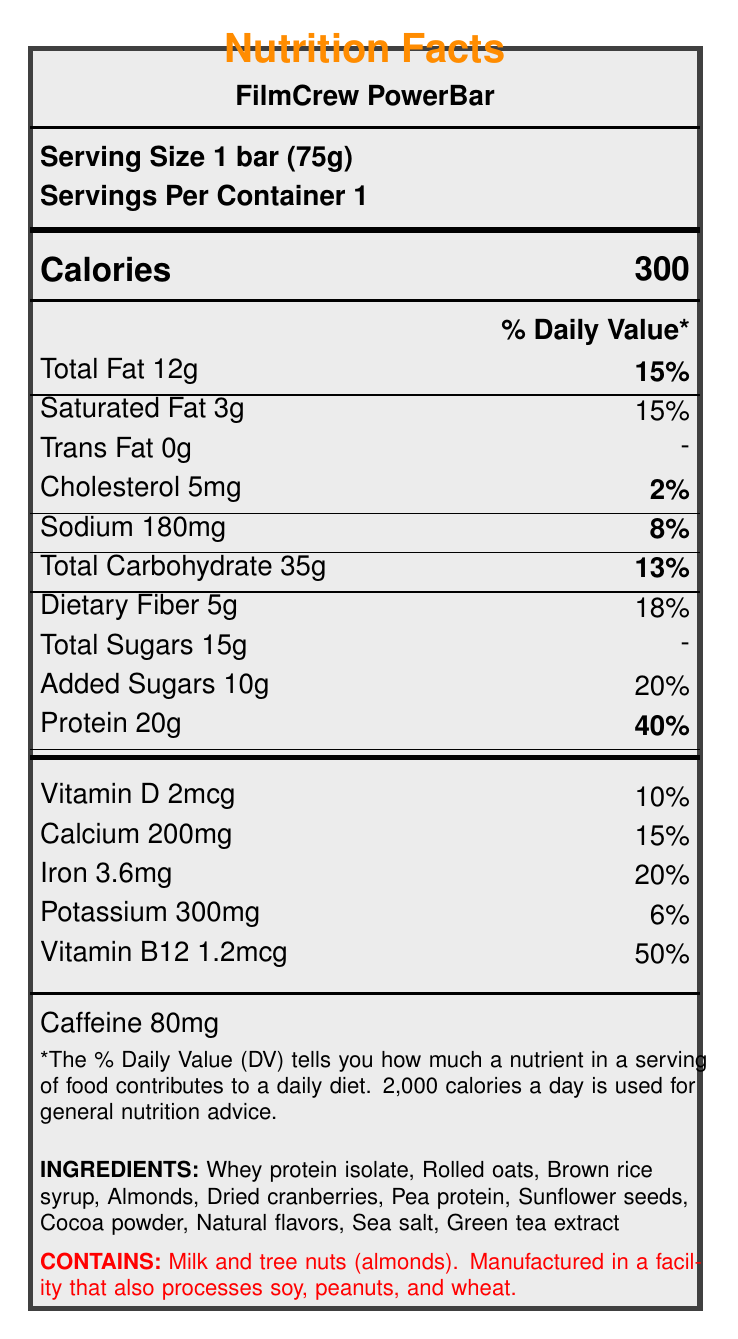what is the serving size of the FilmCrew PowerBar? The serving size is specified as "1 bar (75g)" at the top of the Nutrition Facts label under the "Serving Size" section.
Answer: 1 bar (75g) how many calories are in one serving of the FilmCrew PowerBar? The calories are listed under the "Calories" section in large, bold text that states 300.
Answer: 300 what is the total amount of fat in the FilmCrew PowerBar? The "Total Fat" amount is specified as 12g under the "Nutrient information" section.
Answer: 12g which vitamin has the highest percentage of daily value in the FilmCrew PowerBar? Vitamin B12 has a daily value of 50%, which is higher than other vitamins and minerals listed on the label.
Answer: Vitamin B12 how much protein does the FilmCrew PowerBar provide? The "Protein" amount is specified as 20g under the "Nutrient information" section.
Answer: 20g which of the following ingredients is NOT listed in the FilmCrew PowerBar? A. Whey protein isolate B. Pea protein C. Dried blueberries D. Almonds Dried blueberries are not listed in the ingredient section, whereas whey protein isolate, pea protein, and almonds are.
Answer: C what percentage of the daily value for iron does one serving of the FilmCrew PowerBar provide? A. 10% B. 15% C. 20% D. 25% The label indicates that one serving provides 20% of the daily value for iron.
Answer: C is the FilmCrew PowerBar gluten-free? One of the claims listed on the label states that the product is "Gluten-free."
Answer: Yes does the FilmCrew PowerBar contain any artificial preservatives? The product claims state "No artificial preservatives."
Answer: No summarize the main nutritional highlights of the FilmCrew PowerBar The main highlights include the high protein content, the added benefits of vitamins and minerals, as well as the absence of gluten and artificial preservatives.
Answer: The FilmCrew PowerBar offers 300 calories per serving, with significant nutrients including 20g of protein, 5g of dietary fiber, and 50% of the daily value of Vitamin B12. It contains 12g of total fat, 15g of total sugars, and 80mg of caffeine. It is gluten-free, high in protein, and contains no artificial preservatives. what is the storage recommendation for the FilmCrew PowerBar? The storage instructions state to "Store in a cool, dry place."
Answer: Store in a cool, dry place. who manufactures the FilmCrew PowerBar? The manufacturer information at the end of the document specifies "Produced by VFX Nutrition Labs, Los Angeles, CA 90028."
Answer: VFX Nutrition Labs, Los Angeles, CA 90028 how much caffeine is in the FilmCrew PowerBar? The "Caffeine" amount is specified as 80mg under its respective section.
Answer: 80mg what is the main allergen warning associated with the FilmCrew PowerBar? The allergen information clearly states the presence of milk and tree nuts (almonds) and informs about potential cross-contamination with soy, peanuts, and wheat.
Answer: Contains milk and tree nuts (almonds). Manufactured in a facility that also processes soy, peanuts, and wheat. how many servings are there per container? The number of servings per container is specified as 1 under the "Servings Per Container" section.
Answer: 1 does the FilmCrew PowerBar have any certifications? The label mentions that the product is "Non-GMO Project Verified" and "Kosher."
Answer: Yes, it is Non-GMO Project Verified and Kosher. what is the daily value percentage of saturated fat for the FilmCrew PowerBar? The daily value percentage for saturated fat is indicated as 15% under the "Nutrient information" section.
Answer: 15% how many grams of dietary fiber does one FilmCrew PowerBar contain? The "Dietary Fiber" amount is listed as 5g in the "Nutrient information."
Answer: 5g how many grams of sugars are added in the FilmCrew PowerBar? The "Added Sugars" amount is specified as 10g under the "Nutrient information."
Answer: 10g does the FilmCrew PowerBar contain dried cranberries? Dried cranberries are listed as one of the ingredients.
Answer: Yes what is the expiration date of the FilmCrew PowerBar? The document does not provide information about the expiration date; it only advises to consume before the date stamped on the package.
Answer: Cannot be determined 